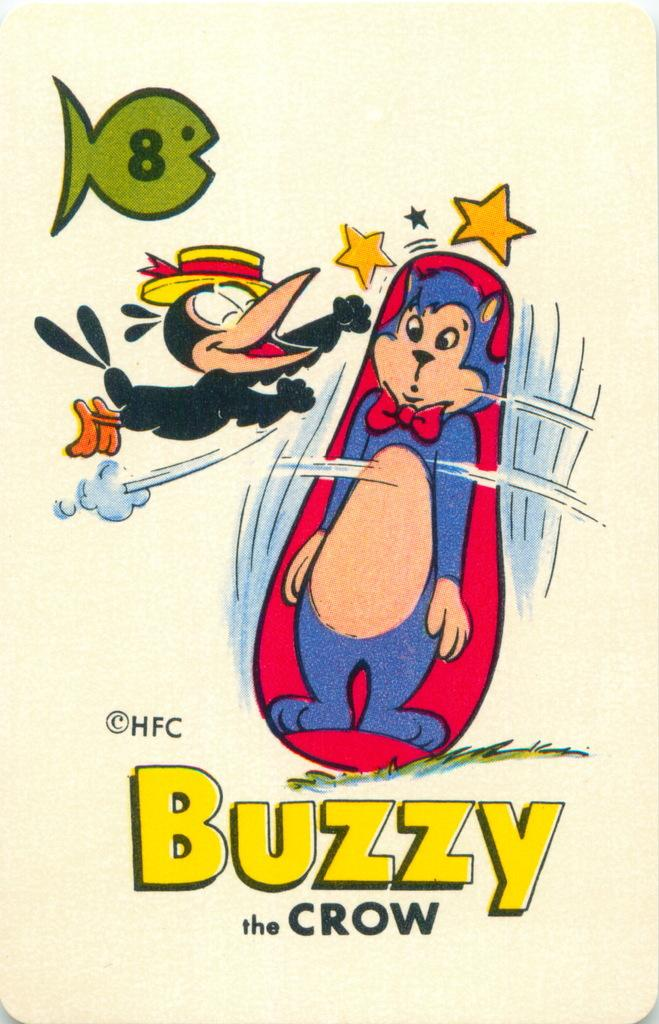Provide a one-sentence caption for the provided image. a Buzzy the Crow cartoon advert with a crow and a cat punching bag. 